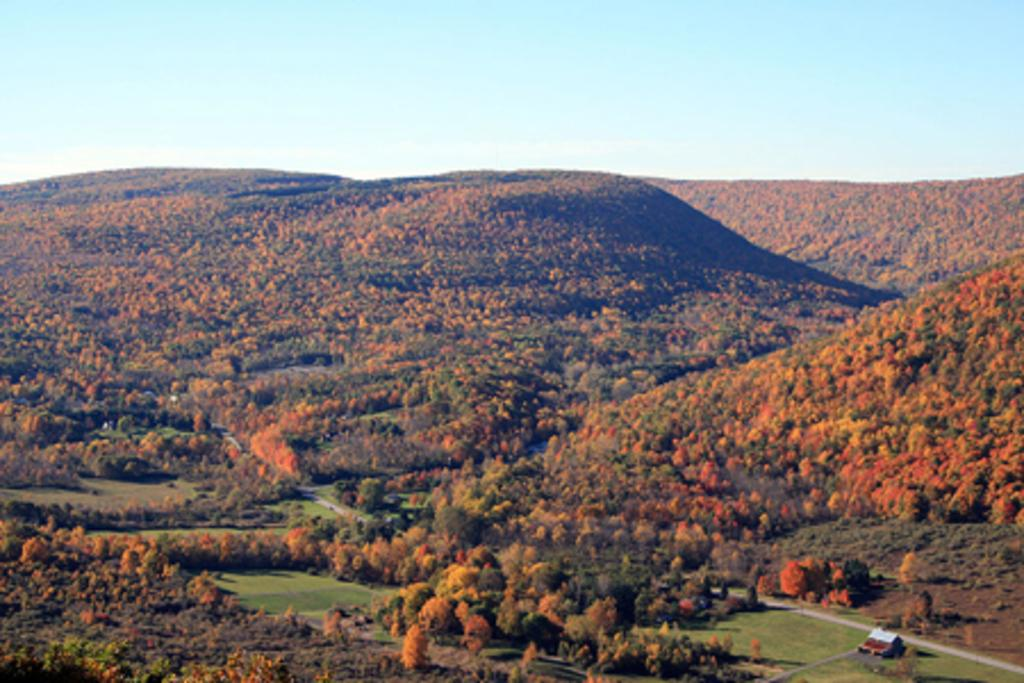What type of vegetation is present in the image? There are many trees and plants in the image. What geographical feature can be seen in the image? There are mountains in the image. How are the mountains covered? The mountains are covered with plants. What type of ground cover is visible at the bottom of the image? There is grass at the bottom of the image. What part of the natural environment is visible in the background of the image? The sky is visible in the background of the image. What type of cork can be seen in the image? There is no cork present in the image. What kind of cake is being served in the image? There is no cake present in the image. 